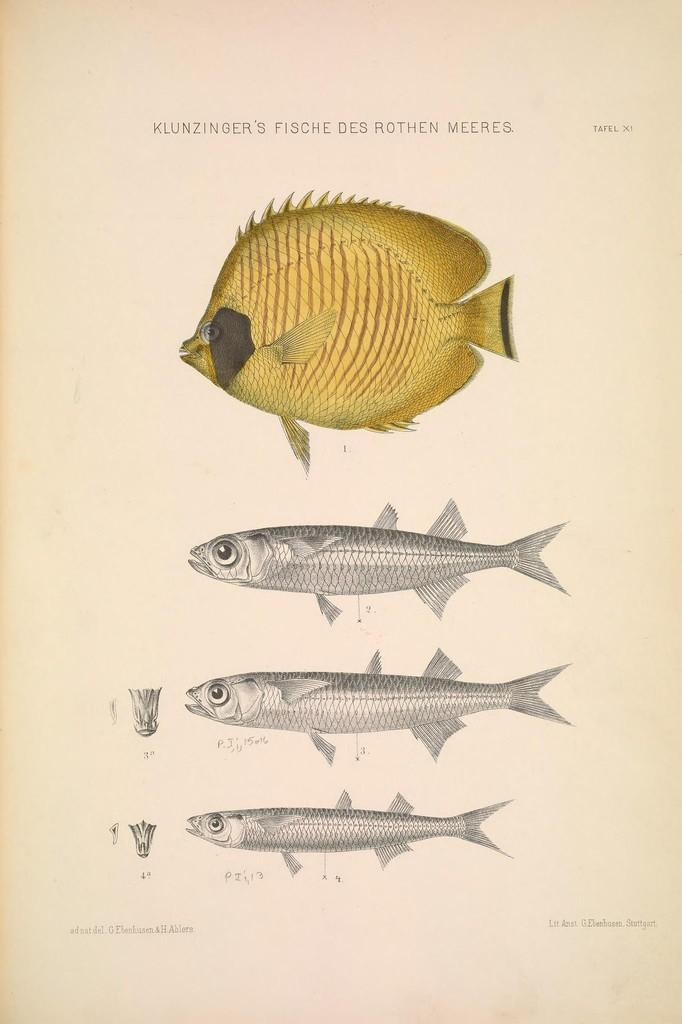What is depicted on the paper in the image? There are pictures of fishes on the paper. What else can be found on the paper besides the pictures of fishes? There is text on the paper. Who is the writer of the text on the paper in the image? There is no information about the writer of the text in the image. What type of cap is visible on the paper in the image? There is no cap present in the image. 